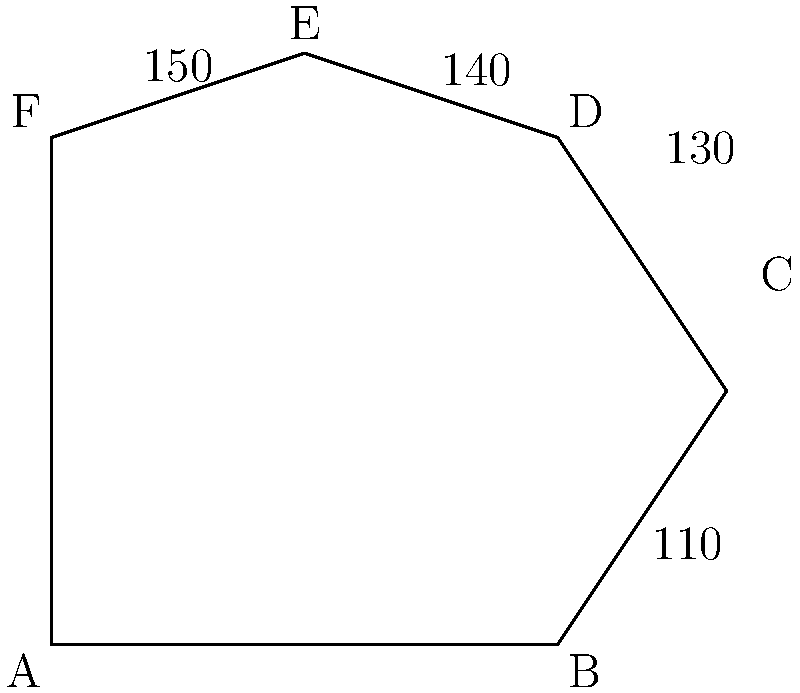In the complex hexagon ABCDEF, representing the multifaceted life of a busy parent, four of the interior angles are given: $\angle ABC = 110°$, $\angle BCD = 130°$, $\angle CDE = 140°$, and $\angle DEF = 150°$. What is the measure of $\angle FAB$? Let's approach this step-by-step:

1) First, recall that the sum of interior angles of a hexagon is $(n-2) \times 180°$, where $n$ is the number of sides. For a hexagon, this is:

   $(6-2) \times 180° = 4 \times 180° = 720°$

2) We know four of the six angles:
   $110° + 130° + 140° + 150° = 530°$

3) Let's call the unknown angles $x$ (for $\angle EFA$) and $y$ (for $\angle FAB$).

4) We can set up an equation:
   $530° + x + y = 720°$

5) Simplify:
   $x + y = 720° - 530° = 190°$

6) Now, we need one more piece of information. In a hexagon, opposite angles are supplementary, meaning they add up to 180°. $\angle FAB$ is opposite to $\angle CDE$, so:

   $y + 140° = 180°$

7) Solve for $y$:
   $y = 180° - 140° = 40°$

Therefore, $\angle FAB = 40°$.
Answer: $40°$ 